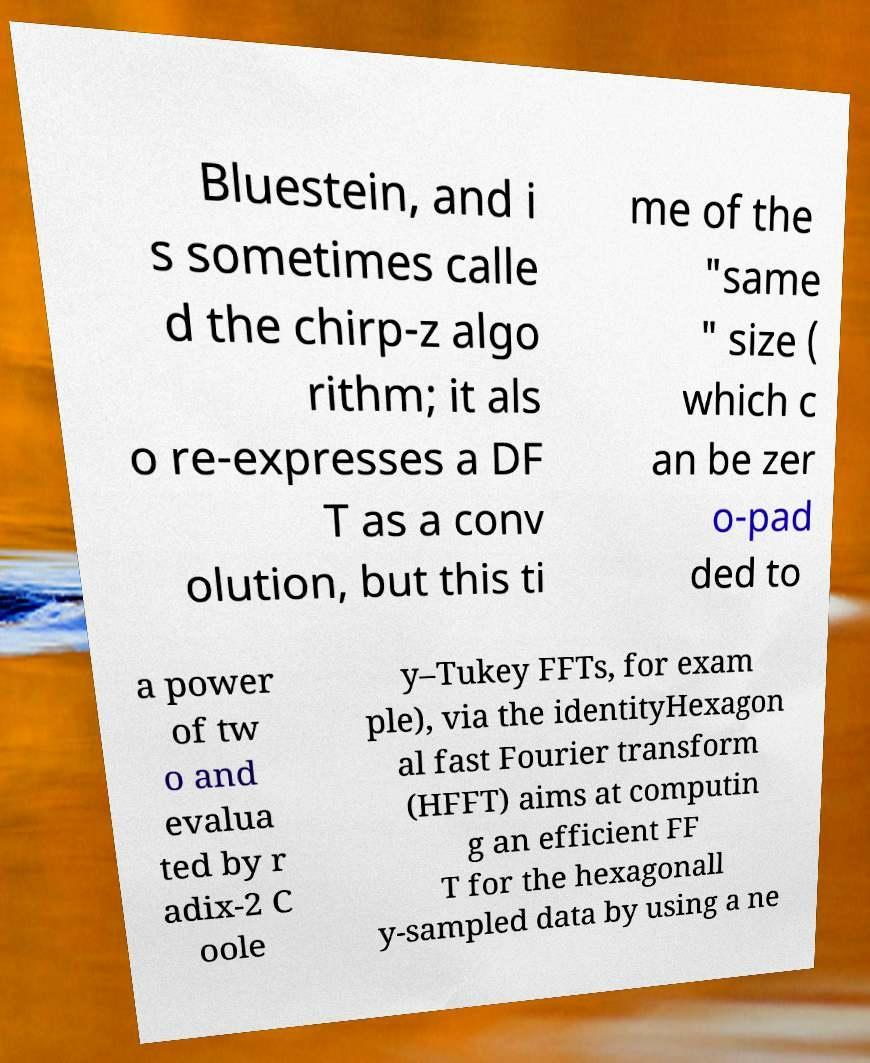For documentation purposes, I need the text within this image transcribed. Could you provide that? Bluestein, and i s sometimes calle d the chirp-z algo rithm; it als o re-expresses a DF T as a conv olution, but this ti me of the "same " size ( which c an be zer o-pad ded to a power of tw o and evalua ted by r adix-2 C oole y–Tukey FFTs, for exam ple), via the identityHexagon al fast Fourier transform (HFFT) aims at computin g an efficient FF T for the hexagonall y-sampled data by using a ne 